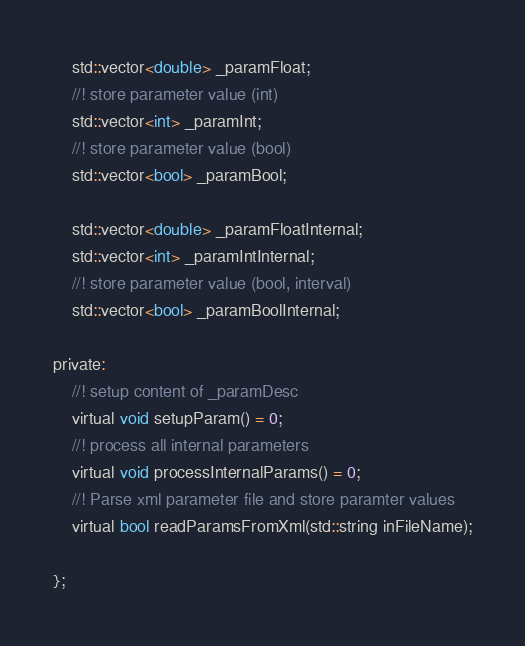<code> <loc_0><loc_0><loc_500><loc_500><_C_>	std::vector<double> _paramFloat;
	//! store parameter value (int)
	std::vector<int> _paramInt;
	//! store parameter value (bool)
	std::vector<bool> _paramBool;

	std::vector<double> _paramFloatInternal;
	std::vector<int> _paramIntInternal;
	//! store parameter value (bool, interval)
	std::vector<bool> _paramBoolInternal;

private:
	//! setup content of _paramDesc
	virtual void setupParam() = 0;
	//! process all internal parameters
	virtual void processInternalParams() = 0;
	//! Parse xml parameter file and store paramter values
	virtual bool readParamsFromXml(std::string inFileName);

};</code> 